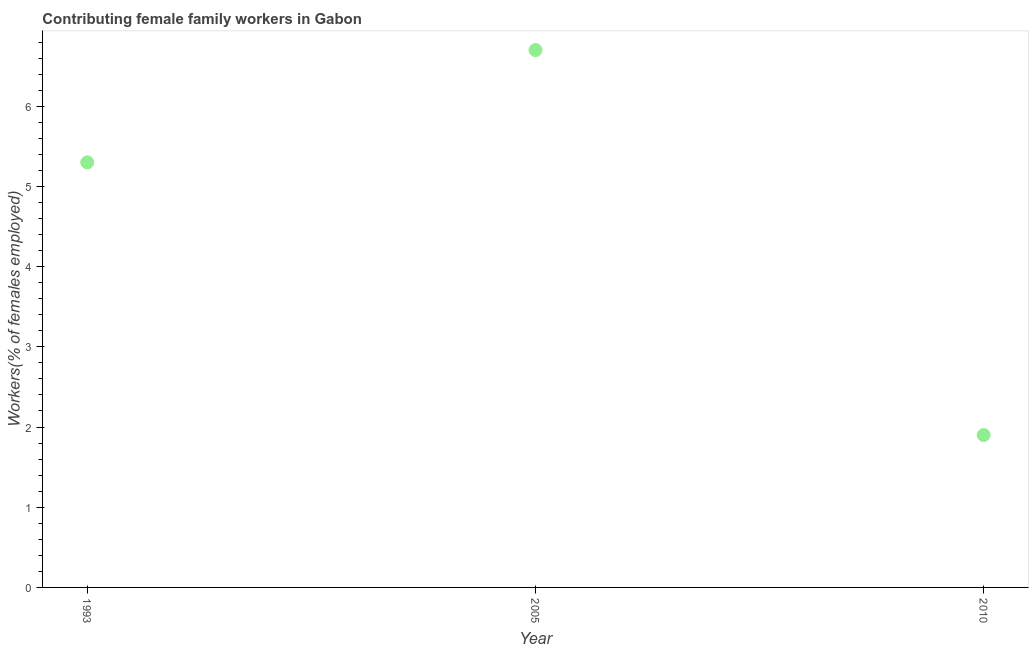What is the contributing female family workers in 1993?
Your answer should be compact. 5.3. Across all years, what is the maximum contributing female family workers?
Provide a short and direct response. 6.7. Across all years, what is the minimum contributing female family workers?
Provide a succinct answer. 1.9. In which year was the contributing female family workers maximum?
Provide a short and direct response. 2005. What is the sum of the contributing female family workers?
Make the answer very short. 13.9. What is the difference between the contributing female family workers in 2005 and 2010?
Keep it short and to the point. 4.8. What is the average contributing female family workers per year?
Offer a very short reply. 4.63. What is the median contributing female family workers?
Provide a short and direct response. 5.3. What is the ratio of the contributing female family workers in 1993 to that in 2010?
Ensure brevity in your answer.  2.79. Is the contributing female family workers in 1993 less than that in 2005?
Your response must be concise. Yes. What is the difference between the highest and the second highest contributing female family workers?
Provide a succinct answer. 1.4. What is the difference between the highest and the lowest contributing female family workers?
Your response must be concise. 4.8. Does the contributing female family workers monotonically increase over the years?
Your answer should be compact. No. How many dotlines are there?
Provide a short and direct response. 1. Are the values on the major ticks of Y-axis written in scientific E-notation?
Your answer should be compact. No. Does the graph contain grids?
Offer a very short reply. No. What is the title of the graph?
Your answer should be very brief. Contributing female family workers in Gabon. What is the label or title of the X-axis?
Offer a very short reply. Year. What is the label or title of the Y-axis?
Your response must be concise. Workers(% of females employed). What is the Workers(% of females employed) in 1993?
Offer a terse response. 5.3. What is the Workers(% of females employed) in 2005?
Your answer should be compact. 6.7. What is the Workers(% of females employed) in 2010?
Make the answer very short. 1.9. What is the difference between the Workers(% of females employed) in 1993 and 2010?
Ensure brevity in your answer.  3.4. What is the ratio of the Workers(% of females employed) in 1993 to that in 2005?
Provide a short and direct response. 0.79. What is the ratio of the Workers(% of females employed) in 1993 to that in 2010?
Your answer should be compact. 2.79. What is the ratio of the Workers(% of females employed) in 2005 to that in 2010?
Provide a short and direct response. 3.53. 